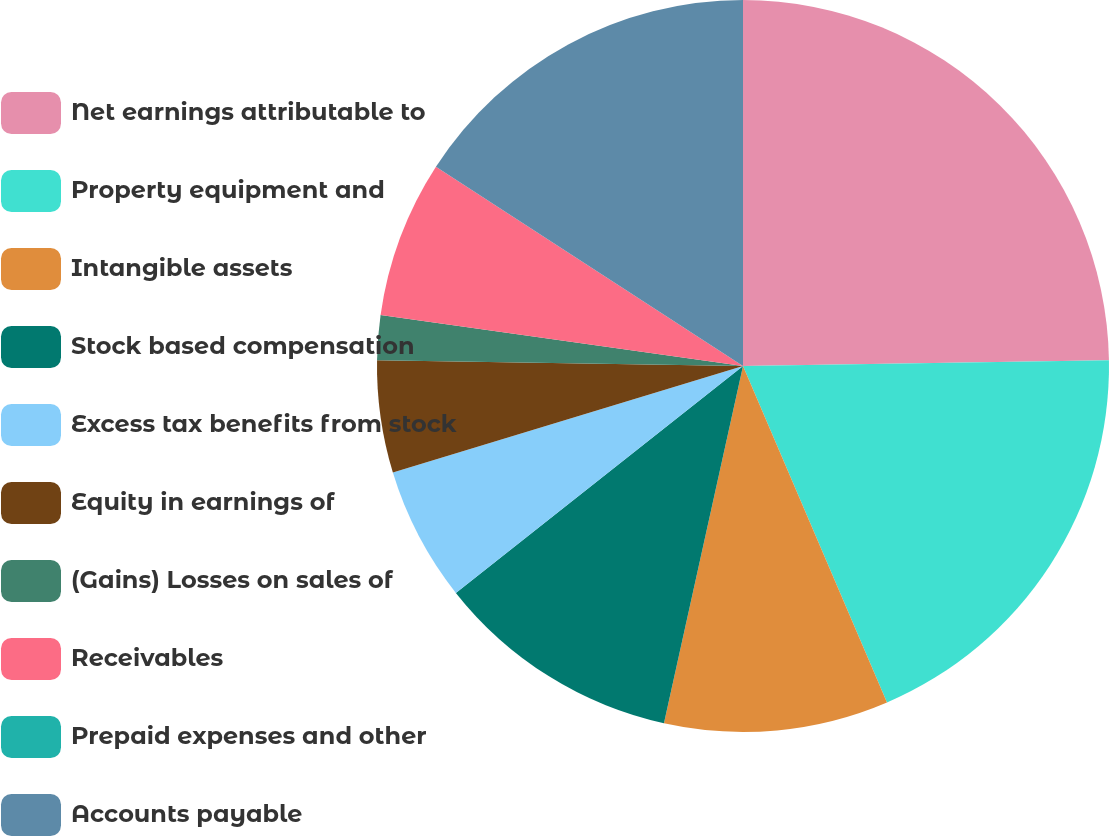Convert chart to OTSL. <chart><loc_0><loc_0><loc_500><loc_500><pie_chart><fcel>Net earnings attributable to<fcel>Property equipment and<fcel>Intangible assets<fcel>Stock based compensation<fcel>Excess tax benefits from stock<fcel>Equity in earnings of<fcel>(Gains) Losses on sales of<fcel>Receivables<fcel>Prepaid expenses and other<fcel>Accounts payable<nl><fcel>24.75%<fcel>18.81%<fcel>9.9%<fcel>10.89%<fcel>5.94%<fcel>4.95%<fcel>1.98%<fcel>6.93%<fcel>0.0%<fcel>15.84%<nl></chart> 